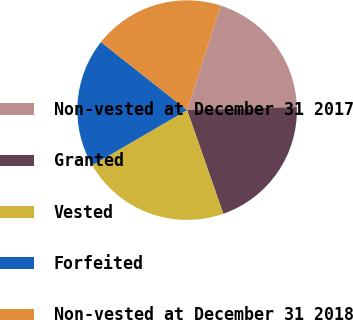Convert chart to OTSL. <chart><loc_0><loc_0><loc_500><loc_500><pie_chart><fcel>Non-vested at December 31 2017<fcel>Granted<fcel>Vested<fcel>Forfeited<fcel>Non-vested at December 31 2018<nl><fcel>19.61%<fcel>20.1%<fcel>21.97%<fcel>19.02%<fcel>19.31%<nl></chart> 